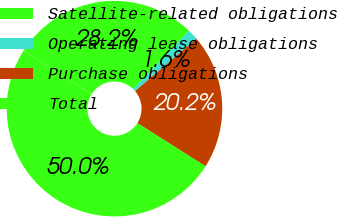<chart> <loc_0><loc_0><loc_500><loc_500><pie_chart><fcel>Satellite-related obligations<fcel>Operating lease obligations<fcel>Purchase obligations<fcel>Total<nl><fcel>28.19%<fcel>1.58%<fcel>20.23%<fcel>50.0%<nl></chart> 